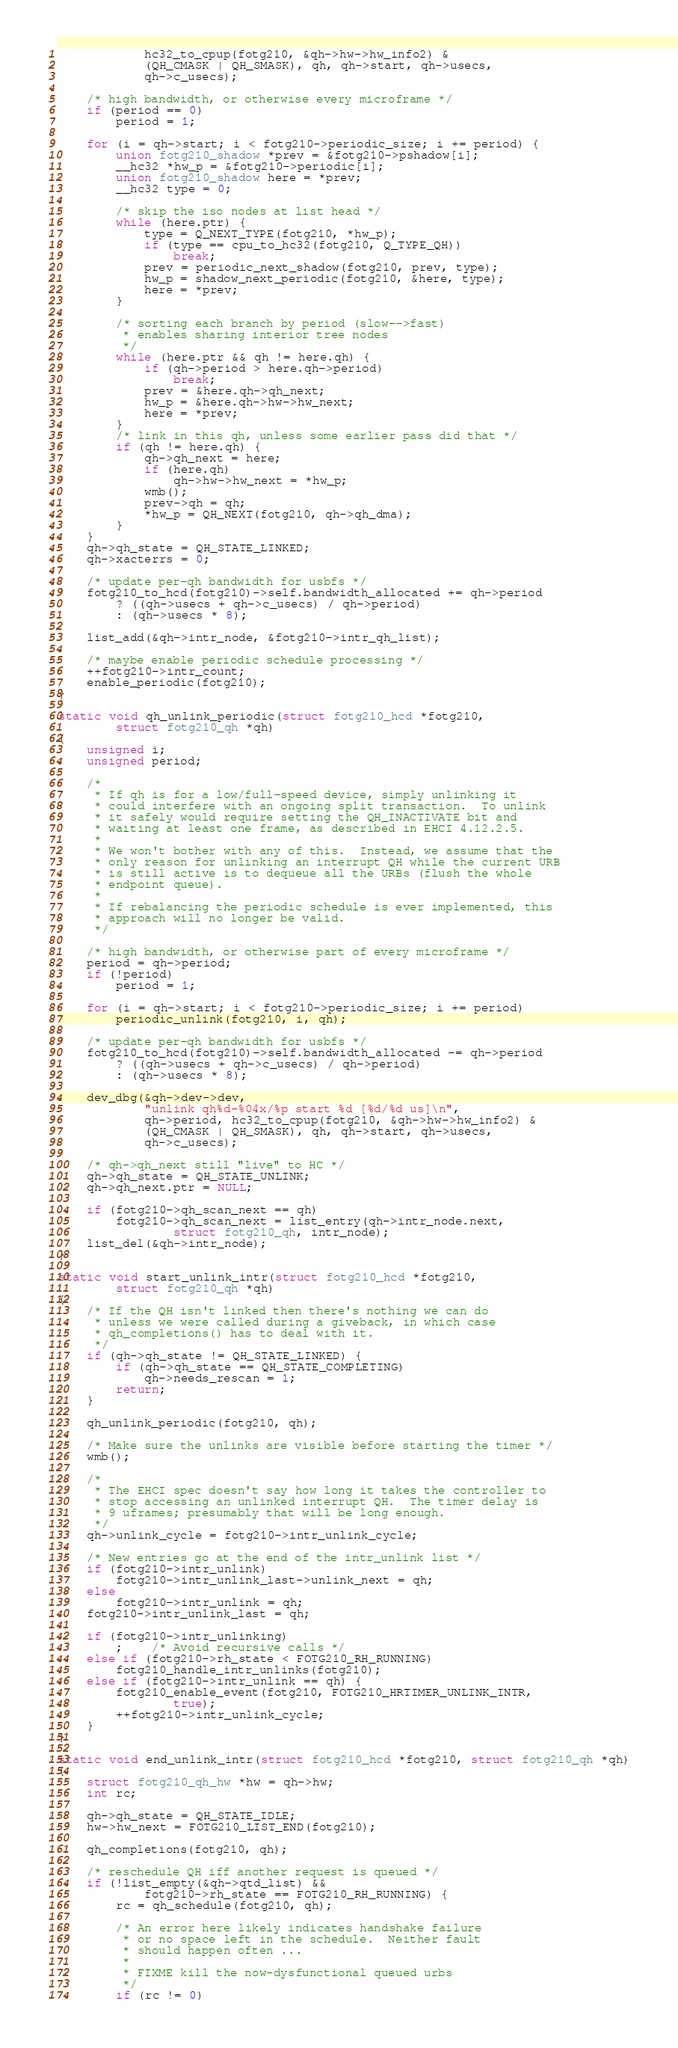<code> <loc_0><loc_0><loc_500><loc_500><_C_>			hc32_to_cpup(fotg210, &qh->hw->hw_info2) &
			(QH_CMASK | QH_SMASK), qh, qh->start, qh->usecs,
			qh->c_usecs);

	/* high bandwidth, or otherwise every microframe */
	if (period == 0)
		period = 1;

	for (i = qh->start; i < fotg210->periodic_size; i += period) {
		union fotg210_shadow *prev = &fotg210->pshadow[i];
		__hc32 *hw_p = &fotg210->periodic[i];
		union fotg210_shadow here = *prev;
		__hc32 type = 0;

		/* skip the iso nodes at list head */
		while (here.ptr) {
			type = Q_NEXT_TYPE(fotg210, *hw_p);
			if (type == cpu_to_hc32(fotg210, Q_TYPE_QH))
				break;
			prev = periodic_next_shadow(fotg210, prev, type);
			hw_p = shadow_next_periodic(fotg210, &here, type);
			here = *prev;
		}

		/* sorting each branch by period (slow-->fast)
		 * enables sharing interior tree nodes
		 */
		while (here.ptr && qh != here.qh) {
			if (qh->period > here.qh->period)
				break;
			prev = &here.qh->qh_next;
			hw_p = &here.qh->hw->hw_next;
			here = *prev;
		}
		/* link in this qh, unless some earlier pass did that */
		if (qh != here.qh) {
			qh->qh_next = here;
			if (here.qh)
				qh->hw->hw_next = *hw_p;
			wmb();
			prev->qh = qh;
			*hw_p = QH_NEXT(fotg210, qh->qh_dma);
		}
	}
	qh->qh_state = QH_STATE_LINKED;
	qh->xacterrs = 0;

	/* update per-qh bandwidth for usbfs */
	fotg210_to_hcd(fotg210)->self.bandwidth_allocated += qh->period
		? ((qh->usecs + qh->c_usecs) / qh->period)
		: (qh->usecs * 8);

	list_add(&qh->intr_node, &fotg210->intr_qh_list);

	/* maybe enable periodic schedule processing */
	++fotg210->intr_count;
	enable_periodic(fotg210);
}

static void qh_unlink_periodic(struct fotg210_hcd *fotg210,
		struct fotg210_qh *qh)
{
	unsigned i;
	unsigned period;

	/*
	 * If qh is for a low/full-speed device, simply unlinking it
	 * could interfere with an ongoing split transaction.  To unlink
	 * it safely would require setting the QH_INACTIVATE bit and
	 * waiting at least one frame, as described in EHCI 4.12.2.5.
	 *
	 * We won't bother with any of this.  Instead, we assume that the
	 * only reason for unlinking an interrupt QH while the current URB
	 * is still active is to dequeue all the URBs (flush the whole
	 * endpoint queue).
	 *
	 * If rebalancing the periodic schedule is ever implemented, this
	 * approach will no longer be valid.
	 */

	/* high bandwidth, or otherwise part of every microframe */
	period = qh->period;
	if (!period)
		period = 1;

	for (i = qh->start; i < fotg210->periodic_size; i += period)
		periodic_unlink(fotg210, i, qh);

	/* update per-qh bandwidth for usbfs */
	fotg210_to_hcd(fotg210)->self.bandwidth_allocated -= qh->period
		? ((qh->usecs + qh->c_usecs) / qh->period)
		: (qh->usecs * 8);

	dev_dbg(&qh->dev->dev,
			"unlink qh%d-%04x/%p start %d [%d/%d us]\n",
			qh->period, hc32_to_cpup(fotg210, &qh->hw->hw_info2) &
			(QH_CMASK | QH_SMASK), qh, qh->start, qh->usecs,
			qh->c_usecs);

	/* qh->qh_next still "live" to HC */
	qh->qh_state = QH_STATE_UNLINK;
	qh->qh_next.ptr = NULL;

	if (fotg210->qh_scan_next == qh)
		fotg210->qh_scan_next = list_entry(qh->intr_node.next,
				struct fotg210_qh, intr_node);
	list_del(&qh->intr_node);
}

static void start_unlink_intr(struct fotg210_hcd *fotg210,
		struct fotg210_qh *qh)
{
	/* If the QH isn't linked then there's nothing we can do
	 * unless we were called during a giveback, in which case
	 * qh_completions() has to deal with it.
	 */
	if (qh->qh_state != QH_STATE_LINKED) {
		if (qh->qh_state == QH_STATE_COMPLETING)
			qh->needs_rescan = 1;
		return;
	}

	qh_unlink_periodic(fotg210, qh);

	/* Make sure the unlinks are visible before starting the timer */
	wmb();

	/*
	 * The EHCI spec doesn't say how long it takes the controller to
	 * stop accessing an unlinked interrupt QH.  The timer delay is
	 * 9 uframes; presumably that will be long enough.
	 */
	qh->unlink_cycle = fotg210->intr_unlink_cycle;

	/* New entries go at the end of the intr_unlink list */
	if (fotg210->intr_unlink)
		fotg210->intr_unlink_last->unlink_next = qh;
	else
		fotg210->intr_unlink = qh;
	fotg210->intr_unlink_last = qh;

	if (fotg210->intr_unlinking)
		;	/* Avoid recursive calls */
	else if (fotg210->rh_state < FOTG210_RH_RUNNING)
		fotg210_handle_intr_unlinks(fotg210);
	else if (fotg210->intr_unlink == qh) {
		fotg210_enable_event(fotg210, FOTG210_HRTIMER_UNLINK_INTR,
				true);
		++fotg210->intr_unlink_cycle;
	}
}

static void end_unlink_intr(struct fotg210_hcd *fotg210, struct fotg210_qh *qh)
{
	struct fotg210_qh_hw *hw = qh->hw;
	int rc;

	qh->qh_state = QH_STATE_IDLE;
	hw->hw_next = FOTG210_LIST_END(fotg210);

	qh_completions(fotg210, qh);

	/* reschedule QH iff another request is queued */
	if (!list_empty(&qh->qtd_list) &&
			fotg210->rh_state == FOTG210_RH_RUNNING) {
		rc = qh_schedule(fotg210, qh);

		/* An error here likely indicates handshake failure
		 * or no space left in the schedule.  Neither fault
		 * should happen often ...
		 *
		 * FIXME kill the now-dysfunctional queued urbs
		 */
		if (rc != 0)</code> 